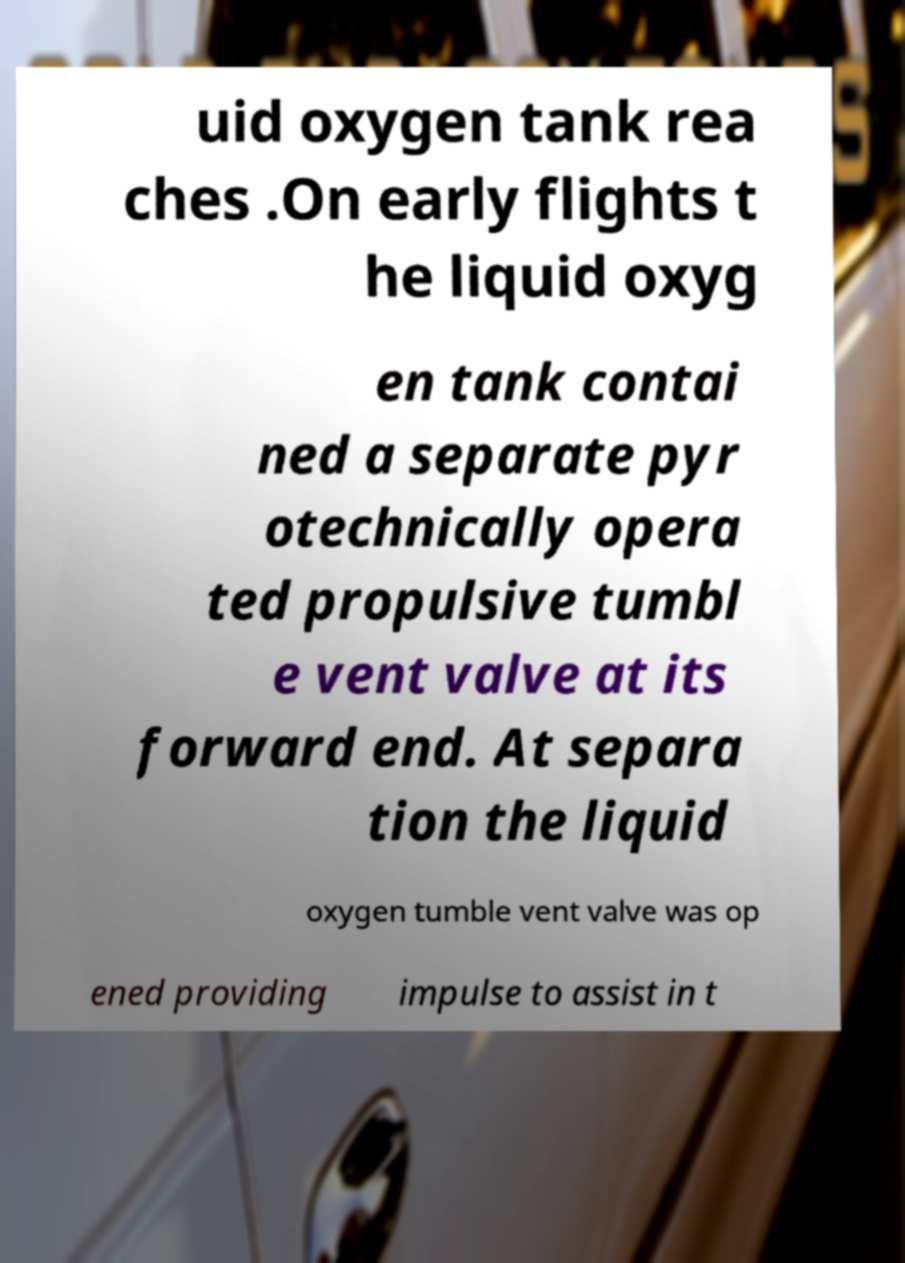Could you assist in decoding the text presented in this image and type it out clearly? uid oxygen tank rea ches .On early flights t he liquid oxyg en tank contai ned a separate pyr otechnically opera ted propulsive tumbl e vent valve at its forward end. At separa tion the liquid oxygen tumble vent valve was op ened providing impulse to assist in t 